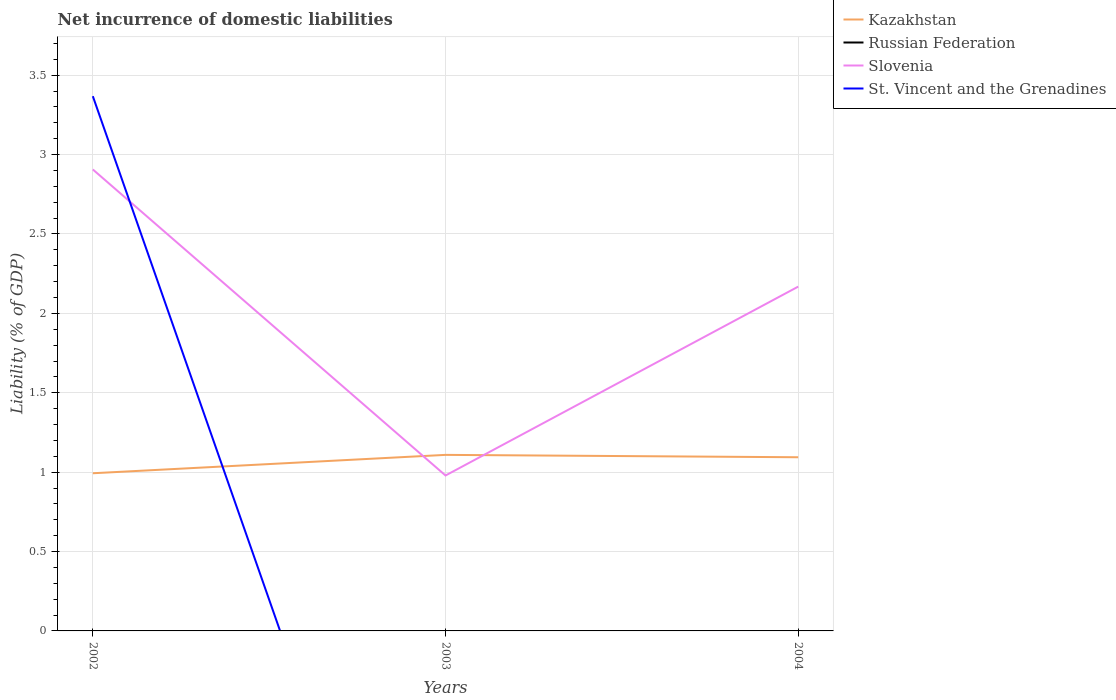How many different coloured lines are there?
Offer a terse response. 3. Across all years, what is the maximum net incurrence of domestic liabilities in Slovenia?
Your answer should be very brief. 0.98. What is the total net incurrence of domestic liabilities in Kazakhstan in the graph?
Your answer should be very brief. -0.12. What is the difference between the highest and the second highest net incurrence of domestic liabilities in Kazakhstan?
Your response must be concise. 0.12. What is the difference between the highest and the lowest net incurrence of domestic liabilities in Kazakhstan?
Keep it short and to the point. 2. Is the net incurrence of domestic liabilities in Russian Federation strictly greater than the net incurrence of domestic liabilities in Kazakhstan over the years?
Ensure brevity in your answer.  Yes. How many lines are there?
Your answer should be compact. 3. How many years are there in the graph?
Give a very brief answer. 3. Does the graph contain grids?
Provide a short and direct response. Yes. Where does the legend appear in the graph?
Keep it short and to the point. Top right. How many legend labels are there?
Your response must be concise. 4. What is the title of the graph?
Your answer should be very brief. Net incurrence of domestic liabilities. What is the label or title of the X-axis?
Keep it short and to the point. Years. What is the label or title of the Y-axis?
Make the answer very short. Liability (% of GDP). What is the Liability (% of GDP) of Kazakhstan in 2002?
Offer a very short reply. 0.99. What is the Liability (% of GDP) of Slovenia in 2002?
Provide a succinct answer. 2.91. What is the Liability (% of GDP) in St. Vincent and the Grenadines in 2002?
Ensure brevity in your answer.  3.37. What is the Liability (% of GDP) of Kazakhstan in 2003?
Offer a very short reply. 1.11. What is the Liability (% of GDP) in Russian Federation in 2003?
Your answer should be very brief. 0. What is the Liability (% of GDP) of Slovenia in 2003?
Provide a short and direct response. 0.98. What is the Liability (% of GDP) of Kazakhstan in 2004?
Ensure brevity in your answer.  1.09. What is the Liability (% of GDP) in Russian Federation in 2004?
Offer a terse response. 0. What is the Liability (% of GDP) of Slovenia in 2004?
Provide a short and direct response. 2.17. What is the Liability (% of GDP) of St. Vincent and the Grenadines in 2004?
Provide a succinct answer. 0. Across all years, what is the maximum Liability (% of GDP) of Kazakhstan?
Give a very brief answer. 1.11. Across all years, what is the maximum Liability (% of GDP) of Slovenia?
Provide a succinct answer. 2.91. Across all years, what is the maximum Liability (% of GDP) in St. Vincent and the Grenadines?
Your answer should be compact. 3.37. Across all years, what is the minimum Liability (% of GDP) in Kazakhstan?
Your answer should be compact. 0.99. Across all years, what is the minimum Liability (% of GDP) in Slovenia?
Ensure brevity in your answer.  0.98. What is the total Liability (% of GDP) in Kazakhstan in the graph?
Your response must be concise. 3.2. What is the total Liability (% of GDP) of Russian Federation in the graph?
Offer a very short reply. 0. What is the total Liability (% of GDP) in Slovenia in the graph?
Offer a very short reply. 6.05. What is the total Liability (% of GDP) of St. Vincent and the Grenadines in the graph?
Your answer should be compact. 3.37. What is the difference between the Liability (% of GDP) of Kazakhstan in 2002 and that in 2003?
Keep it short and to the point. -0.12. What is the difference between the Liability (% of GDP) in Slovenia in 2002 and that in 2003?
Ensure brevity in your answer.  1.93. What is the difference between the Liability (% of GDP) of Kazakhstan in 2002 and that in 2004?
Give a very brief answer. -0.1. What is the difference between the Liability (% of GDP) in Slovenia in 2002 and that in 2004?
Your answer should be very brief. 0.74. What is the difference between the Liability (% of GDP) in Kazakhstan in 2003 and that in 2004?
Your response must be concise. 0.01. What is the difference between the Liability (% of GDP) in Slovenia in 2003 and that in 2004?
Keep it short and to the point. -1.19. What is the difference between the Liability (% of GDP) of Kazakhstan in 2002 and the Liability (% of GDP) of Slovenia in 2003?
Your answer should be very brief. 0.01. What is the difference between the Liability (% of GDP) of Kazakhstan in 2002 and the Liability (% of GDP) of Slovenia in 2004?
Give a very brief answer. -1.18. What is the difference between the Liability (% of GDP) of Kazakhstan in 2003 and the Liability (% of GDP) of Slovenia in 2004?
Your response must be concise. -1.06. What is the average Liability (% of GDP) in Kazakhstan per year?
Offer a terse response. 1.07. What is the average Liability (% of GDP) in Slovenia per year?
Ensure brevity in your answer.  2.02. What is the average Liability (% of GDP) of St. Vincent and the Grenadines per year?
Your answer should be compact. 1.12. In the year 2002, what is the difference between the Liability (% of GDP) in Kazakhstan and Liability (% of GDP) in Slovenia?
Provide a short and direct response. -1.91. In the year 2002, what is the difference between the Liability (% of GDP) of Kazakhstan and Liability (% of GDP) of St. Vincent and the Grenadines?
Your response must be concise. -2.37. In the year 2002, what is the difference between the Liability (% of GDP) in Slovenia and Liability (% of GDP) in St. Vincent and the Grenadines?
Ensure brevity in your answer.  -0.46. In the year 2003, what is the difference between the Liability (% of GDP) of Kazakhstan and Liability (% of GDP) of Slovenia?
Provide a succinct answer. 0.13. In the year 2004, what is the difference between the Liability (% of GDP) of Kazakhstan and Liability (% of GDP) of Slovenia?
Your answer should be compact. -1.07. What is the ratio of the Liability (% of GDP) of Kazakhstan in 2002 to that in 2003?
Your answer should be compact. 0.9. What is the ratio of the Liability (% of GDP) in Slovenia in 2002 to that in 2003?
Your response must be concise. 2.97. What is the ratio of the Liability (% of GDP) of Kazakhstan in 2002 to that in 2004?
Your answer should be very brief. 0.91. What is the ratio of the Liability (% of GDP) of Slovenia in 2002 to that in 2004?
Offer a very short reply. 1.34. What is the ratio of the Liability (% of GDP) of Kazakhstan in 2003 to that in 2004?
Keep it short and to the point. 1.01. What is the ratio of the Liability (% of GDP) in Slovenia in 2003 to that in 2004?
Offer a very short reply. 0.45. What is the difference between the highest and the second highest Liability (% of GDP) in Kazakhstan?
Offer a terse response. 0.01. What is the difference between the highest and the second highest Liability (% of GDP) in Slovenia?
Provide a short and direct response. 0.74. What is the difference between the highest and the lowest Liability (% of GDP) of Kazakhstan?
Your answer should be very brief. 0.12. What is the difference between the highest and the lowest Liability (% of GDP) in Slovenia?
Make the answer very short. 1.93. What is the difference between the highest and the lowest Liability (% of GDP) in St. Vincent and the Grenadines?
Keep it short and to the point. 3.37. 